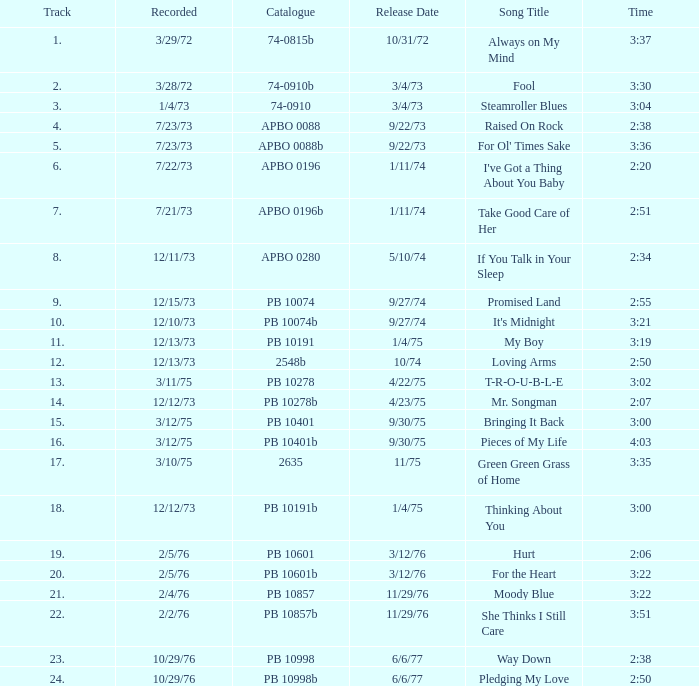Tell me the recorded for time of 2:50 and released date of 6/6/77 with track more than 20 10/29/76. 